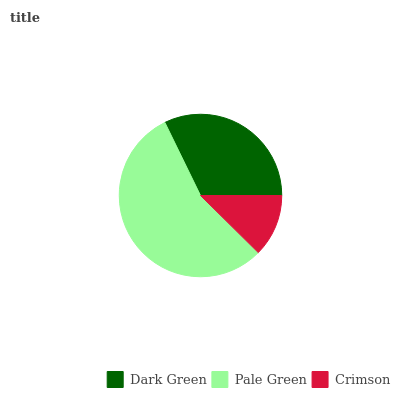Is Crimson the minimum?
Answer yes or no. Yes. Is Pale Green the maximum?
Answer yes or no. Yes. Is Pale Green the minimum?
Answer yes or no. No. Is Crimson the maximum?
Answer yes or no. No. Is Pale Green greater than Crimson?
Answer yes or no. Yes. Is Crimson less than Pale Green?
Answer yes or no. Yes. Is Crimson greater than Pale Green?
Answer yes or no. No. Is Pale Green less than Crimson?
Answer yes or no. No. Is Dark Green the high median?
Answer yes or no. Yes. Is Dark Green the low median?
Answer yes or no. Yes. Is Crimson the high median?
Answer yes or no. No. Is Pale Green the low median?
Answer yes or no. No. 